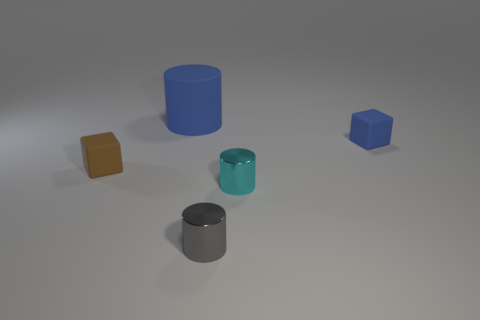Subtract all metallic cylinders. How many cylinders are left? 1 Add 3 large blue rubber objects. How many objects exist? 8 Subtract all cylinders. How many objects are left? 2 Subtract all blue cylinders. How many cylinders are left? 2 Subtract all brown blocks. Subtract all red balls. How many blocks are left? 1 Subtract all cyan balls. How many blue cylinders are left? 1 Subtract all tiny yellow matte blocks. Subtract all small matte cubes. How many objects are left? 3 Add 5 small brown rubber things. How many small brown rubber things are left? 6 Add 2 small cyan objects. How many small cyan objects exist? 3 Subtract 0 red cylinders. How many objects are left? 5 